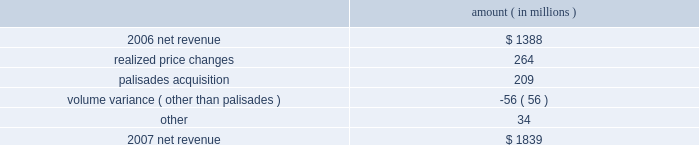Entergy corporation and subsidiaries management's financial discussion and analysis the retail electric price variance resulted from rate increases primarily at entergy louisiana effective september 2006 for the 2005 formula rate plan filing to recover lpsc-approved incremental deferred and ongoing purchased power capacity costs .
The formula rate plan filing is discussed in note 2 to the financial statements .
The volume/weather variance resulted primarily from increased electricity usage in the residential and commercial sectors , including increased usage during the unbilled sales period .
Billed retail electricity usage increased by a total of 1591 gwh , an increase of 1.6% ( 1.6 % ) .
See "critical accounting estimates" herein and note 1 to the financial statements for a discussion of the accounting for unbilled revenues .
The fuel recovery variance is primarily due to the inclusion of grand gulf costs in entergy new orleans' fuel recoveries effective july 1 , 2006 .
In june 2006 , the city council approved the recovery of grand gulf costs through the fuel adjustment clause , without a corresponding change in base rates ( a significant portion of grand gulf costs was previously recovered through base rates ) .
The increase is also due to purchased power costs deferred at entergy louisiana and entergy new orleans as a result of the re-pricing , retroactive to 2003 , of purchased power agreements among entergy system companies as directed by the ferc .
The transmission revenue variance is due to higher rates and the addition of new transmission customers in late-2006 .
The purchased power capacity variance is due to higher capacity charges and new purchased power contracts that began in mid-2006 .
A portion of the variance is due to the amortization of deferred capacity costs and is offset in base revenues due to base rate increases implemented to recover incremental deferred and ongoing purchased power capacity charges at entergy louisiana , as discussed above .
The net wholesale revenue variance is due primarily to 1 ) more energy available for resale at entergy new orleans in 2006 due to the decrease in retail usage caused by customer losses following hurricane katrina and 2 ) the inclusion in 2006 revenue of sales into the wholesale market of entergy new orleans' share of the output of grand gulf , pursuant to city council approval of measures proposed by entergy new orleans to address the reduction in entergy new orleans' retail customer usage caused by hurricane katrina and to provide revenue support for the costs of entergy new orleans' share of grand gulf .
The net wholesale revenue variance is partially offset by the effect of lower wholesale revenues in the third quarter 2006 due to an october 2006 ferc order requiring entergy arkansas to make a refund to a coal plant co-owner resulting from a contract dispute .
Non-utility nuclear following is an analysis of the change in net revenue comparing 2007 to 2006 .
Amount ( in millions ) .
As shown in the table above , net revenue increased for non-utility nuclear by $ 451 million , or 33% ( 33 % ) , for 2007 compared to 2006 primarily due to higher pricing in its contracts to sell power and additional production available resulting from the acquisition of the palisades plant in april 2007 .
Included in the palisades net revenue is $ 50 million of amortization of the palisades purchased power agreement in 2007 , which is non-cash revenue and is discussed in note 15 to the financial statements .
The increase was partially offset by the effect on revenues of four .
What percent of 2017 net revenue did realized price changes account for? 
Computations: (264 / 1839)
Answer: 0.14356. 